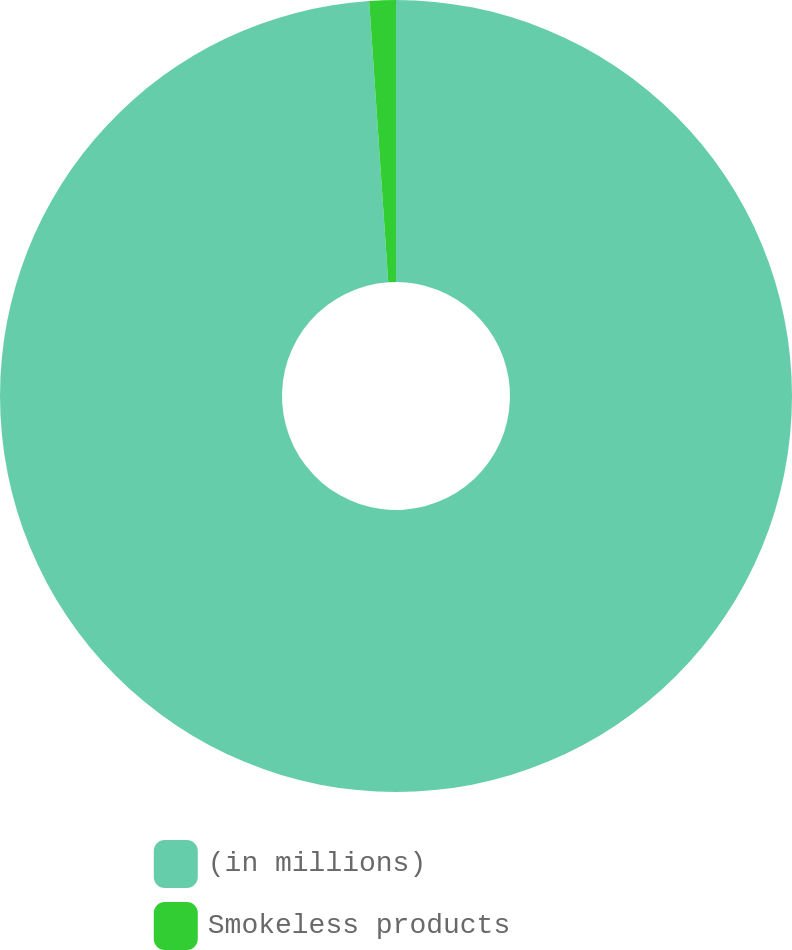Convert chart. <chart><loc_0><loc_0><loc_500><loc_500><pie_chart><fcel>(in millions)<fcel>Smokeless products<nl><fcel>98.92%<fcel>1.08%<nl></chart> 